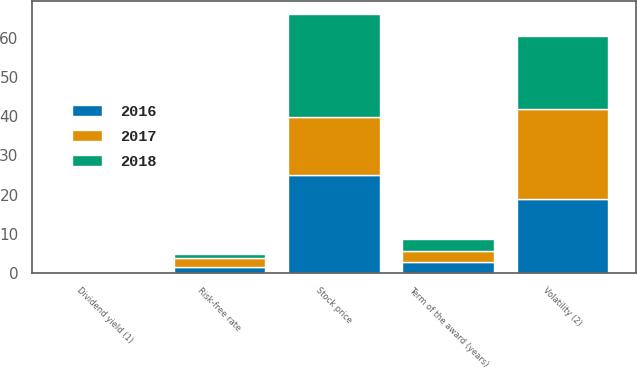<chart> <loc_0><loc_0><loc_500><loc_500><stacked_bar_chart><ecel><fcel>Stock price<fcel>Dividend yield (1)<fcel>Risk-free rate<fcel>Volatility (2)<fcel>Term of the award (years)<nl><fcel>2017<fcel>14.99<fcel>0<fcel>2.39<fcel>22.9<fcel>2.85<nl><fcel>2016<fcel>24.91<fcel>0<fcel>1.45<fcel>18.93<fcel>2.88<nl><fcel>2018<fcel>26.29<fcel>0<fcel>0.87<fcel>18.8<fcel>2.88<nl></chart> 